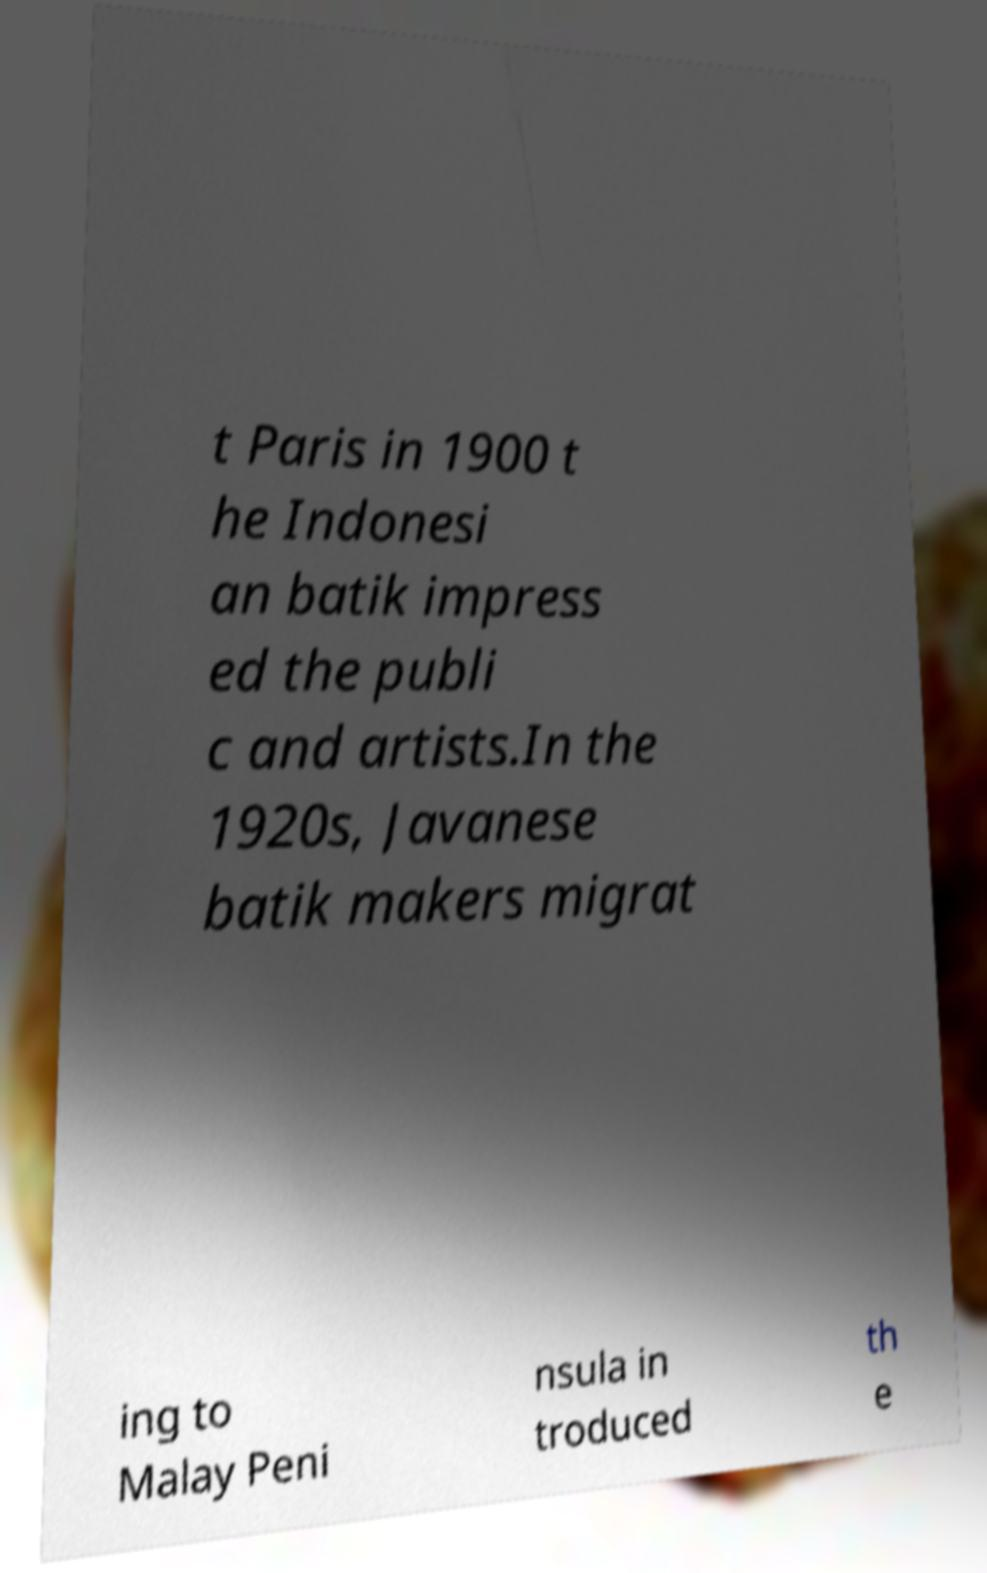Can you read and provide the text displayed in the image?This photo seems to have some interesting text. Can you extract and type it out for me? t Paris in 1900 t he Indonesi an batik impress ed the publi c and artists.In the 1920s, Javanese batik makers migrat ing to Malay Peni nsula in troduced th e 